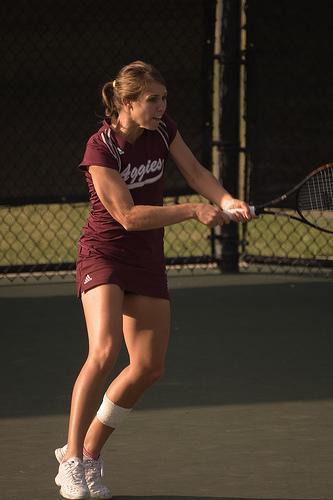How many people are in the photo?
Give a very brief answer. 1. 